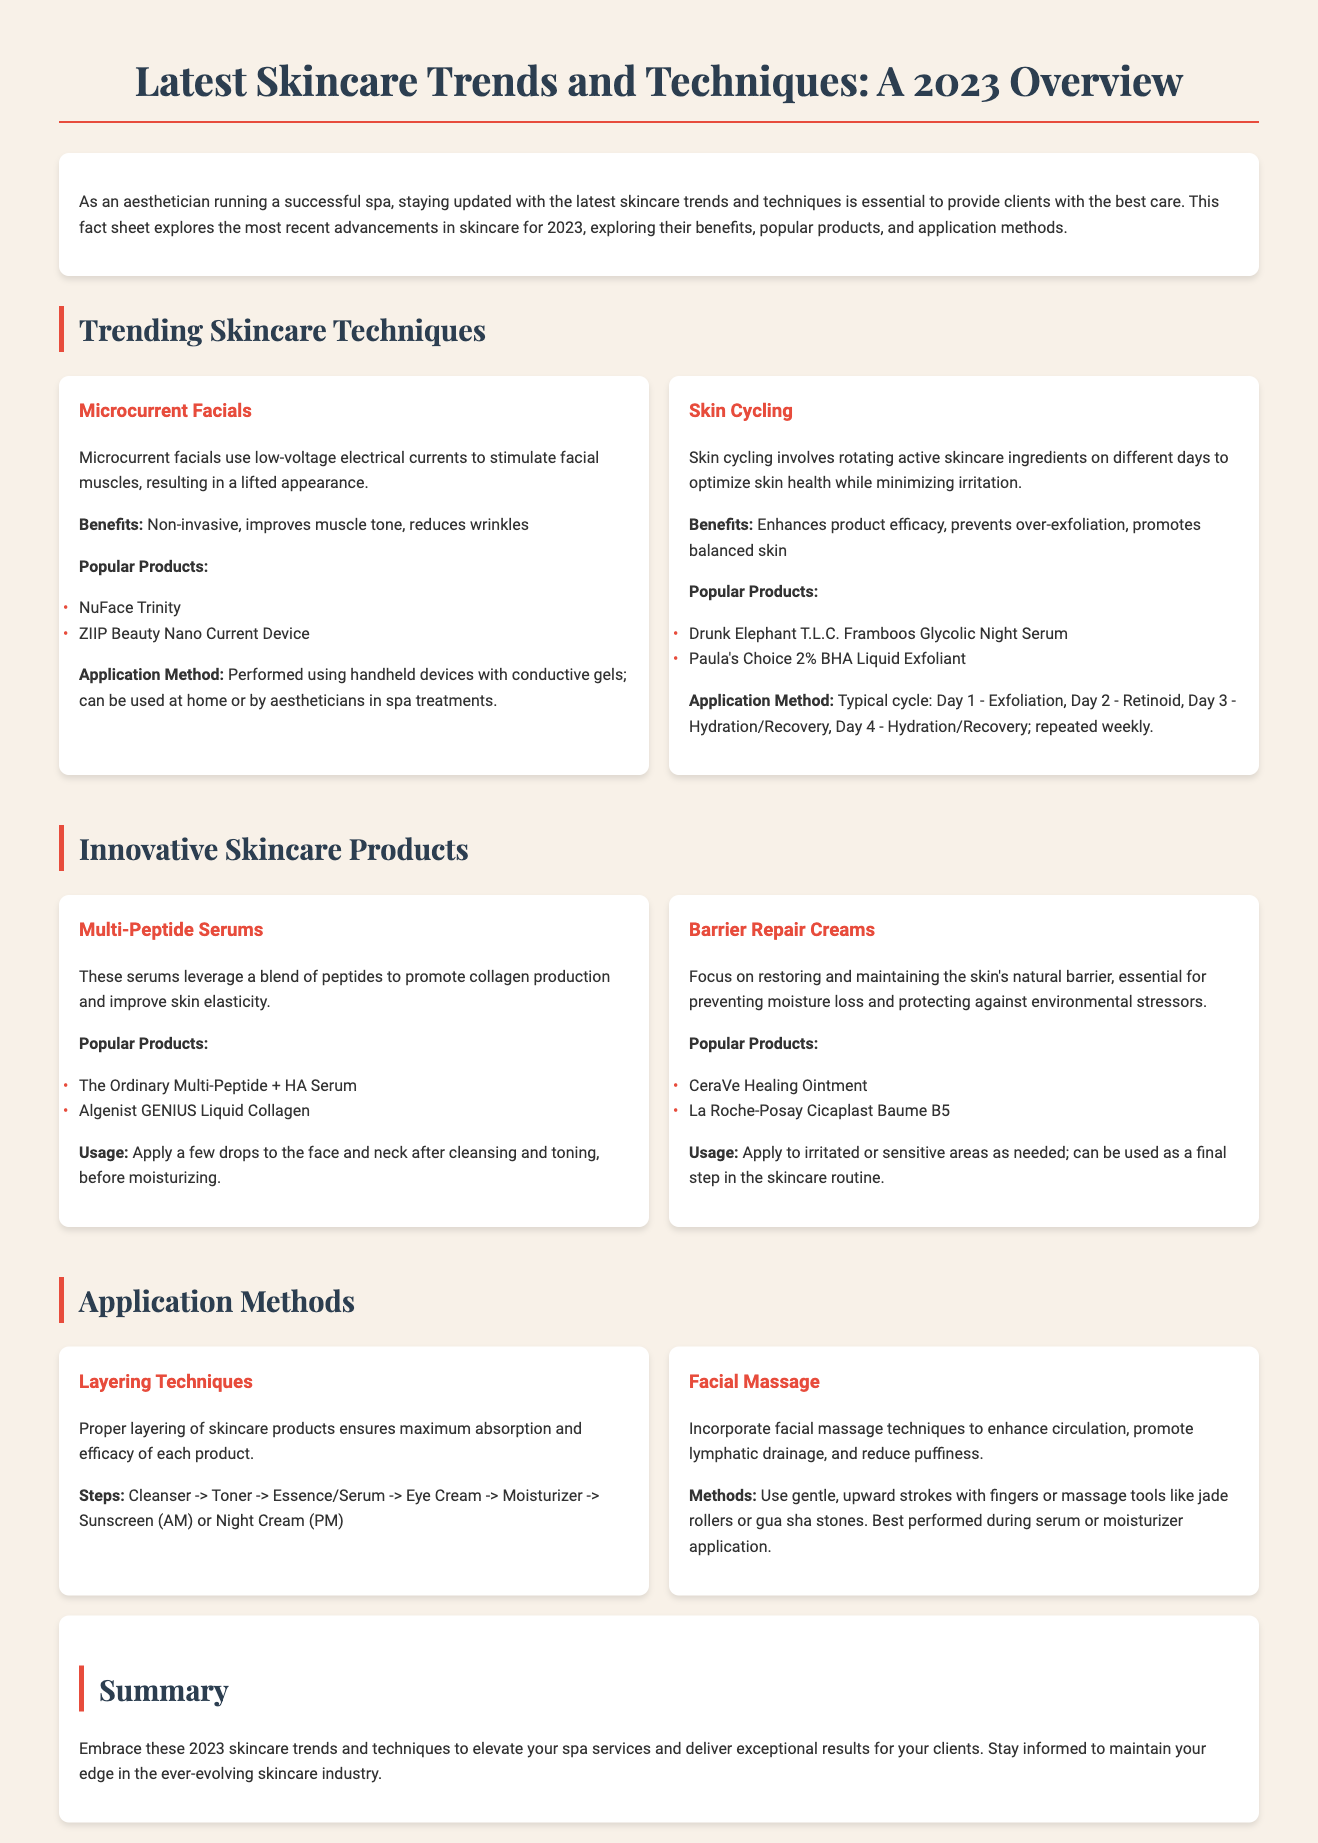What is a key benefit of microcurrent facials? Microcurrent facials improve muscle tone as stated in the benefits section of the document.
Answer: Improves muscle tone What is the first step in the layering technique? The layering technique starts with a cleanser, as indicated in the steps provided in the document.
Answer: Cleanser What is the typical skin cycling order? The document specifies a typical cycle of exfoliation on Day 1, retinoid on Day 2, and hydration/recovery on Days 3 and 4.
Answer: Exfoliation Name a popular product for skin cycling. The document lists Drunk Elephant T.L.C. Framboos Glycolic Night Serum as a popular product for skin cycling.
Answer: Drunk Elephant T.L.C. Framboos Glycolic Night Serum What does facial massage enhance? According to the document, facial massage techniques enhance circulation.
Answer: Circulation Which device is mentioned for microcurrent facials? The NuFace Trinity is a popular device mentioned for microcurrent facials in the document.
Answer: NuFace Trinity What is the primary purpose of barrier repair creams? The document states that barrier repair creams focus on restoring the skin's natural barrier.
Answer: Restoring the skin's natural barrier What type of skincare technique is skin cycling classified as? Skin cycling is classified as a trending skincare technique, according to the section header in the document.
Answer: Trending skincare technique How is multi-peptide serum applied? The document instructs to apply a few drops after cleansing and toning, before moisturizing.
Answer: After cleansing and toning, before moisturizing 